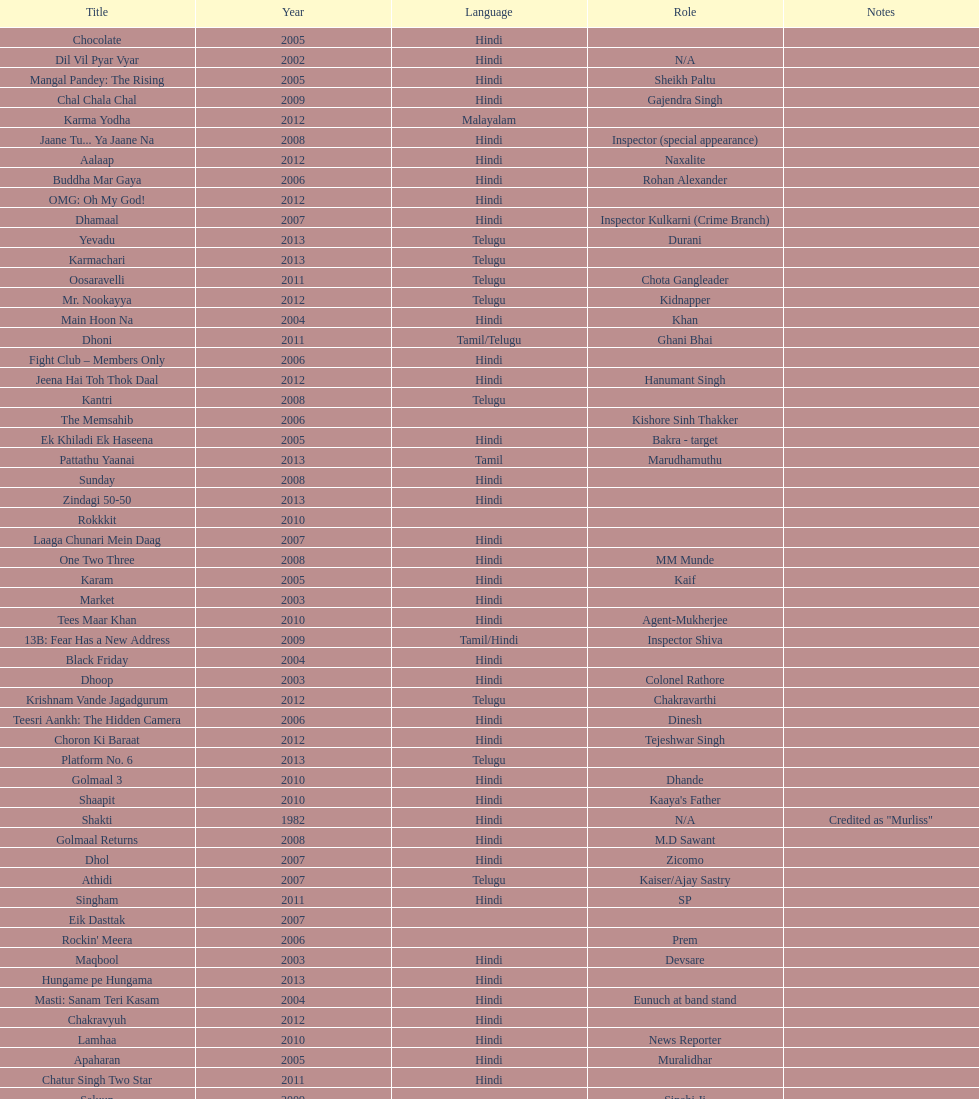How many roles has this actor had? 36. Give me the full table as a dictionary. {'header': ['Title', 'Year', 'Language', 'Role', 'Notes'], 'rows': [['Chocolate', '2005', 'Hindi', '', ''], ['Dil Vil Pyar Vyar', '2002', 'Hindi', 'N/A', ''], ['Mangal Pandey: The Rising', '2005', 'Hindi', 'Sheikh Paltu', ''], ['Chal Chala Chal', '2009', 'Hindi', 'Gajendra Singh', ''], ['Karma Yodha', '2012', 'Malayalam', '', ''], ['Jaane Tu... Ya Jaane Na', '2008', 'Hindi', 'Inspector (special appearance)', ''], ['Aalaap', '2012', 'Hindi', 'Naxalite', ''], ['Buddha Mar Gaya', '2006', 'Hindi', 'Rohan Alexander', ''], ['OMG: Oh My God!', '2012', 'Hindi', '', ''], ['Dhamaal', '2007', 'Hindi', 'Inspector Kulkarni (Crime Branch)', ''], ['Yevadu', '2013', 'Telugu', 'Durani', ''], ['Karmachari', '2013', 'Telugu', '', ''], ['Oosaravelli', '2011', 'Telugu', 'Chota Gangleader', ''], ['Mr. Nookayya', '2012', 'Telugu', 'Kidnapper', ''], ['Main Hoon Na', '2004', 'Hindi', 'Khan', ''], ['Dhoni', '2011', 'Tamil/Telugu', 'Ghani Bhai', ''], ['Fight Club – Members Only', '2006', 'Hindi', '', ''], ['Jeena Hai Toh Thok Daal', '2012', 'Hindi', 'Hanumant Singh', ''], ['Kantri', '2008', 'Telugu', '', ''], ['The Memsahib', '2006', '', 'Kishore Sinh Thakker', ''], ['Ek Khiladi Ek Haseena', '2005', 'Hindi', 'Bakra - target', ''], ['Pattathu Yaanai', '2013', 'Tamil', 'Marudhamuthu', ''], ['Sunday', '2008', 'Hindi', '', ''], ['Zindagi 50-50', '2013', 'Hindi', '', ''], ['Rokkkit', '2010', '', '', ''], ['Laaga Chunari Mein Daag', '2007', 'Hindi', '', ''], ['One Two Three', '2008', 'Hindi', 'MM Munde', ''], ['Karam', '2005', 'Hindi', 'Kaif', ''], ['Market', '2003', 'Hindi', '', ''], ['Tees Maar Khan', '2010', 'Hindi', 'Agent-Mukherjee', ''], ['13B: Fear Has a New Address', '2009', 'Tamil/Hindi', 'Inspector Shiva', ''], ['Black Friday', '2004', 'Hindi', '', ''], ['Dhoop', '2003', 'Hindi', 'Colonel Rathore', ''], ['Krishnam Vande Jagadgurum', '2012', 'Telugu', 'Chakravarthi', ''], ['Teesri Aankh: The Hidden Camera', '2006', 'Hindi', 'Dinesh', ''], ['Choron Ki Baraat', '2012', 'Hindi', 'Tejeshwar Singh', ''], ['Platform No. 6', '2013', 'Telugu', '', ''], ['Golmaal 3', '2010', 'Hindi', 'Dhande', ''], ['Shaapit', '2010', 'Hindi', "Kaaya's Father", ''], ['Shakti', '1982', 'Hindi', 'N/A', 'Credited as "Murliss"'], ['Golmaal Returns', '2008', 'Hindi', 'M.D Sawant', ''], ['Dhol', '2007', 'Hindi', 'Zicomo', ''], ['Athidi', '2007', 'Telugu', 'Kaiser/Ajay Sastry', ''], ['Singham', '2011', 'Hindi', 'SP', ''], ['Eik Dasttak', '2007', '', '', ''], ["Rockin' Meera", '2006', '', 'Prem', ''], ['Maqbool', '2003', 'Hindi', 'Devsare', ''], ['Hungame pe Hungama', '2013', 'Hindi', '', ''], ['Masti: Sanam Teri Kasam', '2004', 'Hindi', 'Eunuch at band stand', ''], ['Chakravyuh', '2012', 'Hindi', '', ''], ['Lamhaa', '2010', 'Hindi', 'News Reporter', ''], ['Apaharan', '2005', 'Hindi', 'Muralidhar', ''], ['Chatur Singh Two Star', '2011', 'Hindi', '', ''], ['Saluun', '2009', '', 'Sipahi Ji', ''], ['Mere Khwabon Mein Jo Aaye', '2009', '', '', ''], ['Kal: Yesterday and Tomorrow', '2005', 'Hindi', 'Sekhar', ''], ['Dabangg', '2010', 'Hindi', '', '']]} 